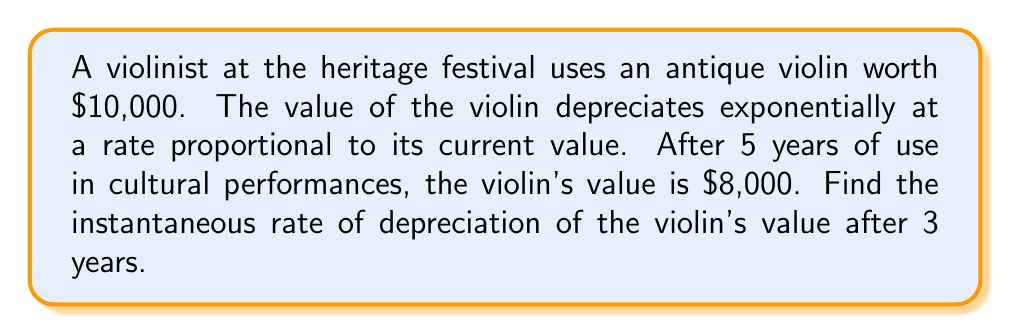Help me with this question. Let's approach this step-by-step:

1) The exponential decay model for the violin's value is:
   $V(t) = V_0 e^{-kt}$
   where $V(t)$ is the value at time $t$, $V_0$ is the initial value, and $k$ is the decay constant.

2) We know:
   $V_0 = 10,000$
   $V(5) = 8,000$

3) Substituting these into the model:
   $8,000 = 10,000 e^{-5k}$

4) Solving for $k$:
   $\frac{8,000}{10,000} = e^{-5k}$
   $0.8 = e^{-5k}$
   $\ln(0.8) = -5k$
   $k = -\frac{\ln(0.8)}{5} \approx 0.0446$

5) Now we have the complete model:
   $V(t) = 10,000 e^{-0.0446t}$

6) To find the instantaneous rate of depreciation at $t=3$, we need to find $V'(3)$:
   $V'(t) = -0.0446 \cdot 10,000 e^{-0.0446t}$
   $V'(3) = -446 e^{-0.1338} \approx -389.62$

7) The negative sign indicates depreciation. The absolute value gives the rate of depreciation.
Answer: $389.62 per year 